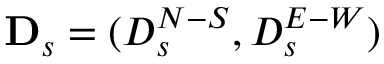Convert formula to latex. <formula><loc_0><loc_0><loc_500><loc_500>D _ { s } = ( D _ { s } ^ { N - S } , D _ { s } ^ { E - W } )</formula> 